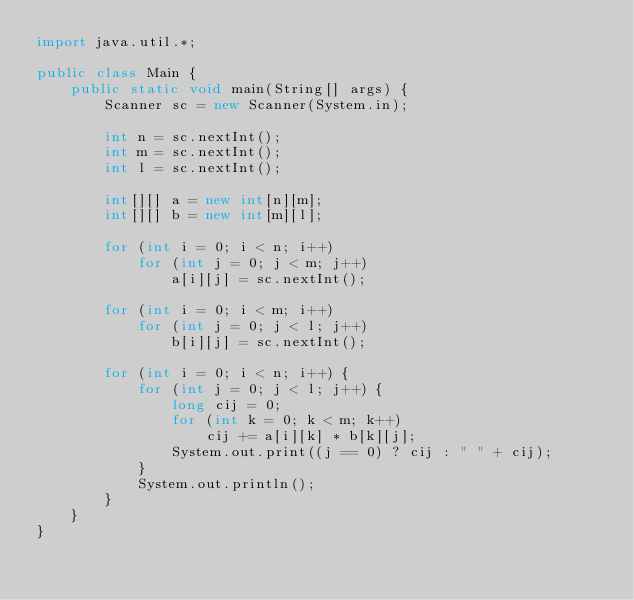Convert code to text. <code><loc_0><loc_0><loc_500><loc_500><_Java_>import java.util.*;

public class Main {
    public static void main(String[] args) {
        Scanner sc = new Scanner(System.in);

        int n = sc.nextInt();
        int m = sc.nextInt();
        int l = sc.nextInt();

        int[][] a = new int[n][m];
        int[][] b = new int[m][l];

        for (int i = 0; i < n; i++)
            for (int j = 0; j < m; j++)
                a[i][j] = sc.nextInt();

        for (int i = 0; i < m; i++)
            for (int j = 0; j < l; j++)
                b[i][j] = sc.nextInt();

        for (int i = 0; i < n; i++) {
            for (int j = 0; j < l; j++) {
                long cij = 0;
                for (int k = 0; k < m; k++)
                    cij += a[i][k] * b[k][j];
                System.out.print((j == 0) ? cij : " " + cij);
            }
            System.out.println();
        }
    }
}
</code> 